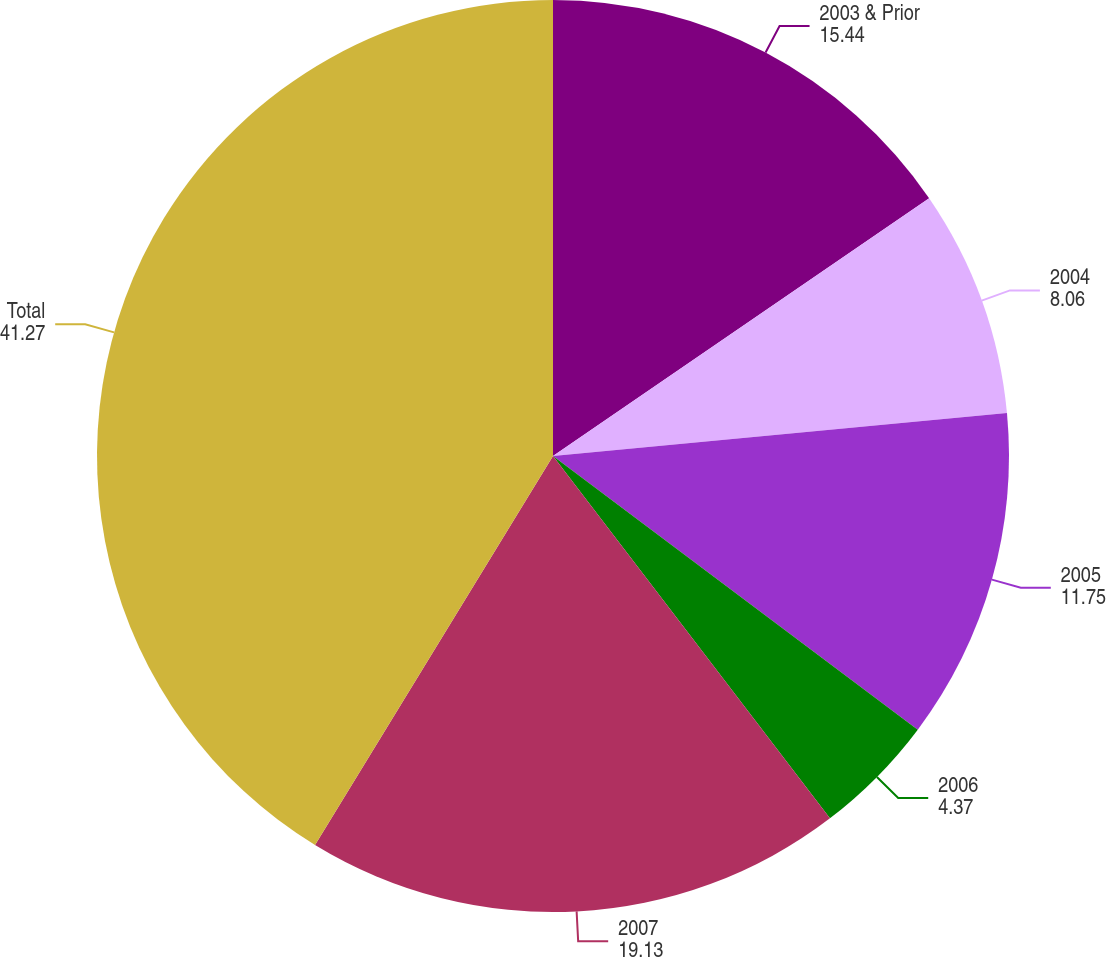Convert chart. <chart><loc_0><loc_0><loc_500><loc_500><pie_chart><fcel>2003 & Prior<fcel>2004<fcel>2005<fcel>2006<fcel>2007<fcel>Total<nl><fcel>15.44%<fcel>8.06%<fcel>11.75%<fcel>4.37%<fcel>19.13%<fcel>41.27%<nl></chart> 